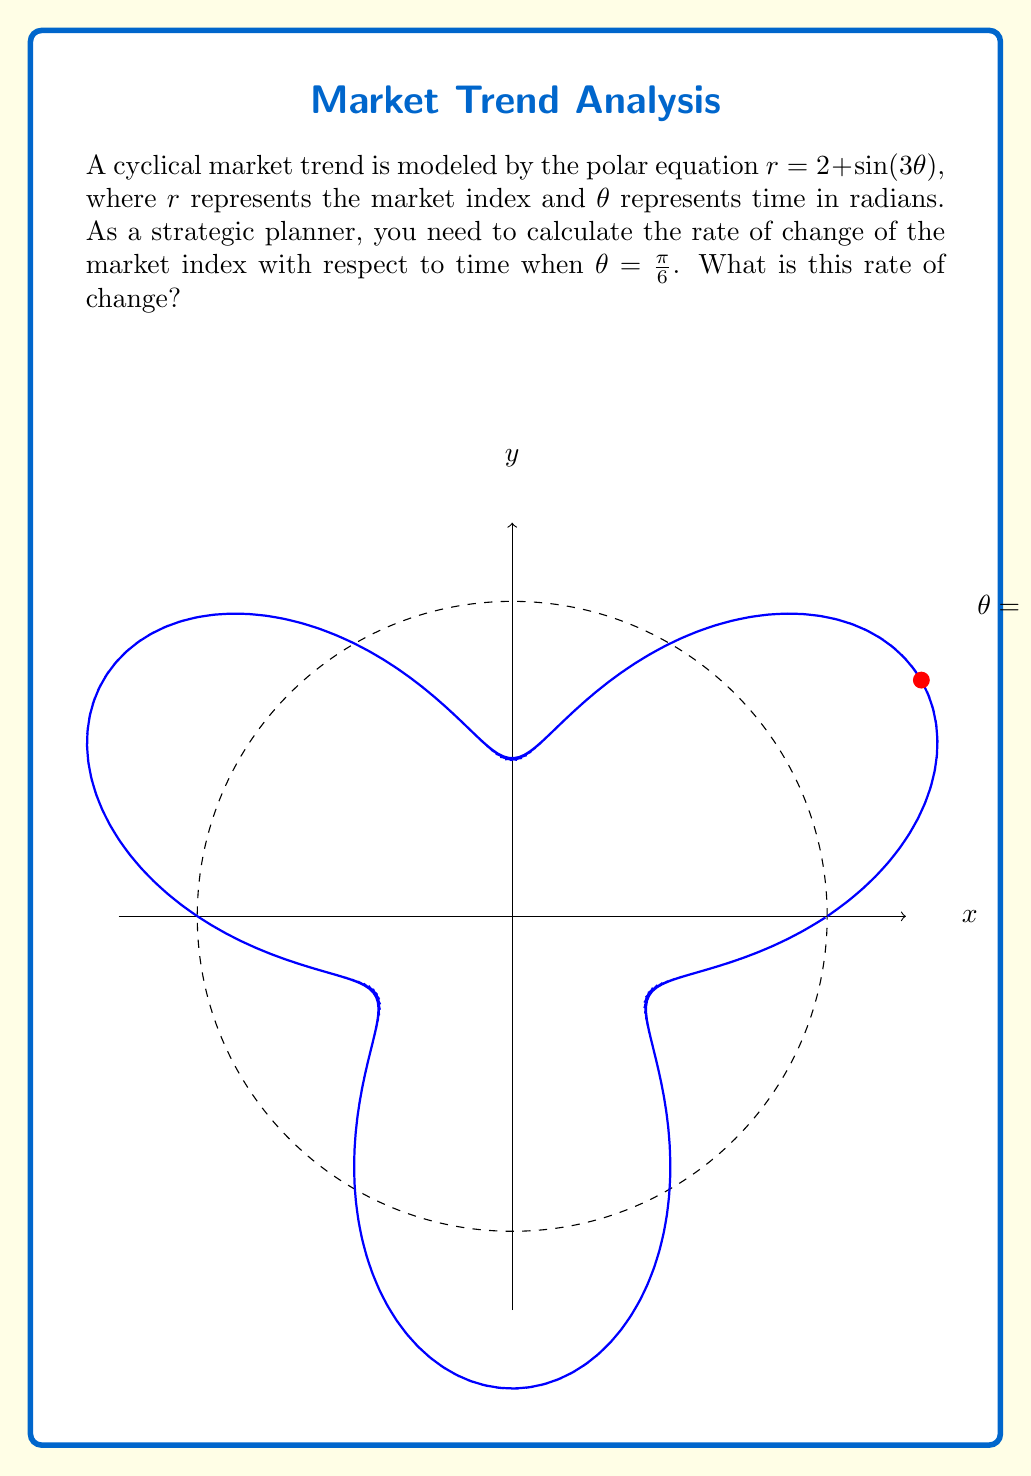Give your solution to this math problem. To solve this problem, we need to use the formula for the polar derivative:

$$\frac{dr}{d\theta} = \frac{dr/dt}{d\theta/dt} = \frac{\dot{r}}{\dot{\theta}}$$

1) First, we need to find $\frac{dr}{d\theta}$:
   $$r = 2 + \sin(3\theta)$$
   $$\frac{dr}{d\theta} = 3\cos(3\theta)$$

2) Now, we use the formula for the rate of change in polar coordinates:
   $$\frac{dx}{d\theta} = \cos(\theta) \cdot r - \sin(\theta) \cdot \frac{dr}{d\theta}$$
   $$\frac{dy}{d\theta} = \sin(\theta) \cdot r + \cos(\theta) \cdot \frac{dr}{d\theta}$$

3) The rate of change of the market index is the magnitude of the vector $(\frac{dx}{d\theta}, \frac{dy}{d\theta})$:
   $$\text{Rate of Change} = \sqrt{(\frac{dx}{d\theta})^2 + (\frac{dy}{d\theta})^2}$$

4) Let's calculate each component at $\theta = \frac{\pi}{6}$:
   $$r = 2 + \sin(\frac{\pi}{2}) = 3$$
   $$\frac{dr}{d\theta} = 3\cos(\frac{\pi}{2}) = 0$$

   $$\frac{dx}{d\theta} = \cos(\frac{\pi}{6}) \cdot 3 - \sin(\frac{\pi}{6}) \cdot 0 = \frac{3\sqrt{3}}{2}$$
   $$\frac{dy}{d\theta} = \sin(\frac{\pi}{6}) \cdot 3 + \cos(\frac{\pi}{6}) \cdot 0 = \frac{3}{2}$$

5) Now we can calculate the rate of change:
   $$\text{Rate of Change} = \sqrt{(\frac{3\sqrt{3}}{2})^2 + (\frac{3}{2})^2} = \sqrt{\frac{27}{4} + \frac{9}{4}} = \sqrt{9} = 3$$

Therefore, the rate of change of the market index at $\theta = \frac{\pi}{6}$ is 3 units per radian.
Answer: 3 units per radian 